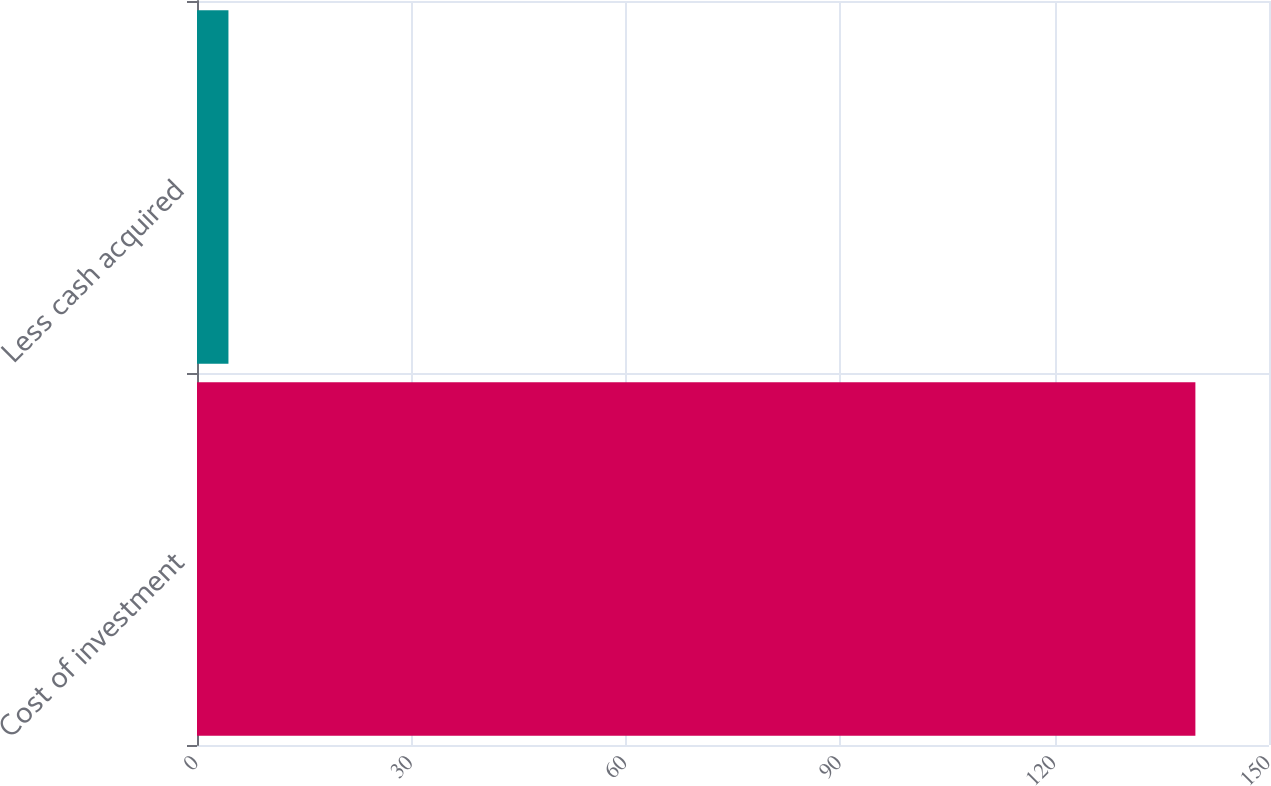<chart> <loc_0><loc_0><loc_500><loc_500><bar_chart><fcel>Cost of investment<fcel>Less cash acquired<nl><fcel>139.7<fcel>4.4<nl></chart> 